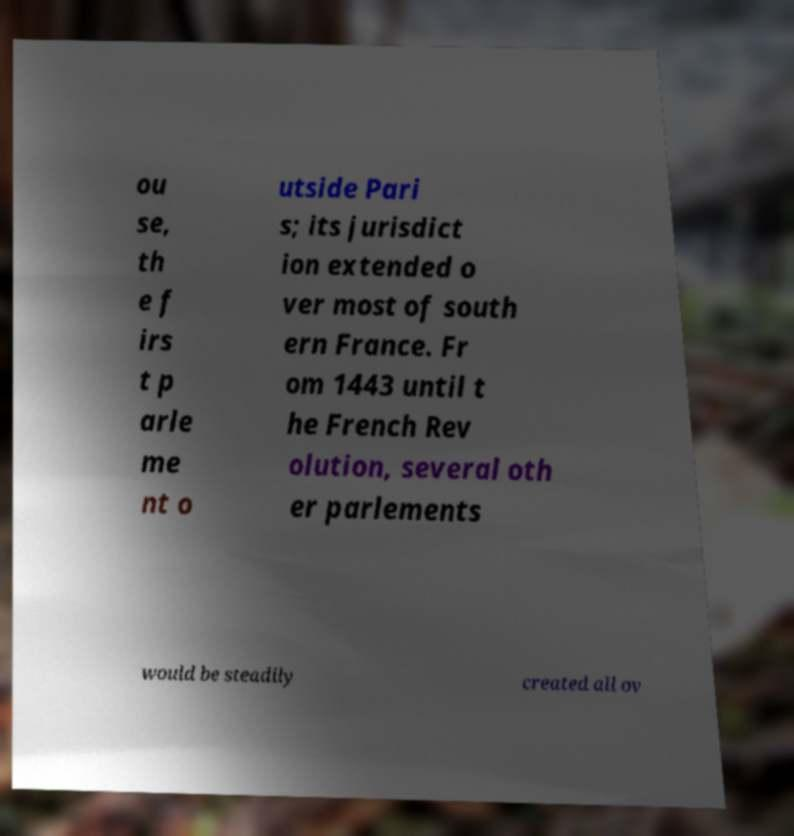I need the written content from this picture converted into text. Can you do that? ou se, th e f irs t p arle me nt o utside Pari s; its jurisdict ion extended o ver most of south ern France. Fr om 1443 until t he French Rev olution, several oth er parlements would be steadily created all ov 